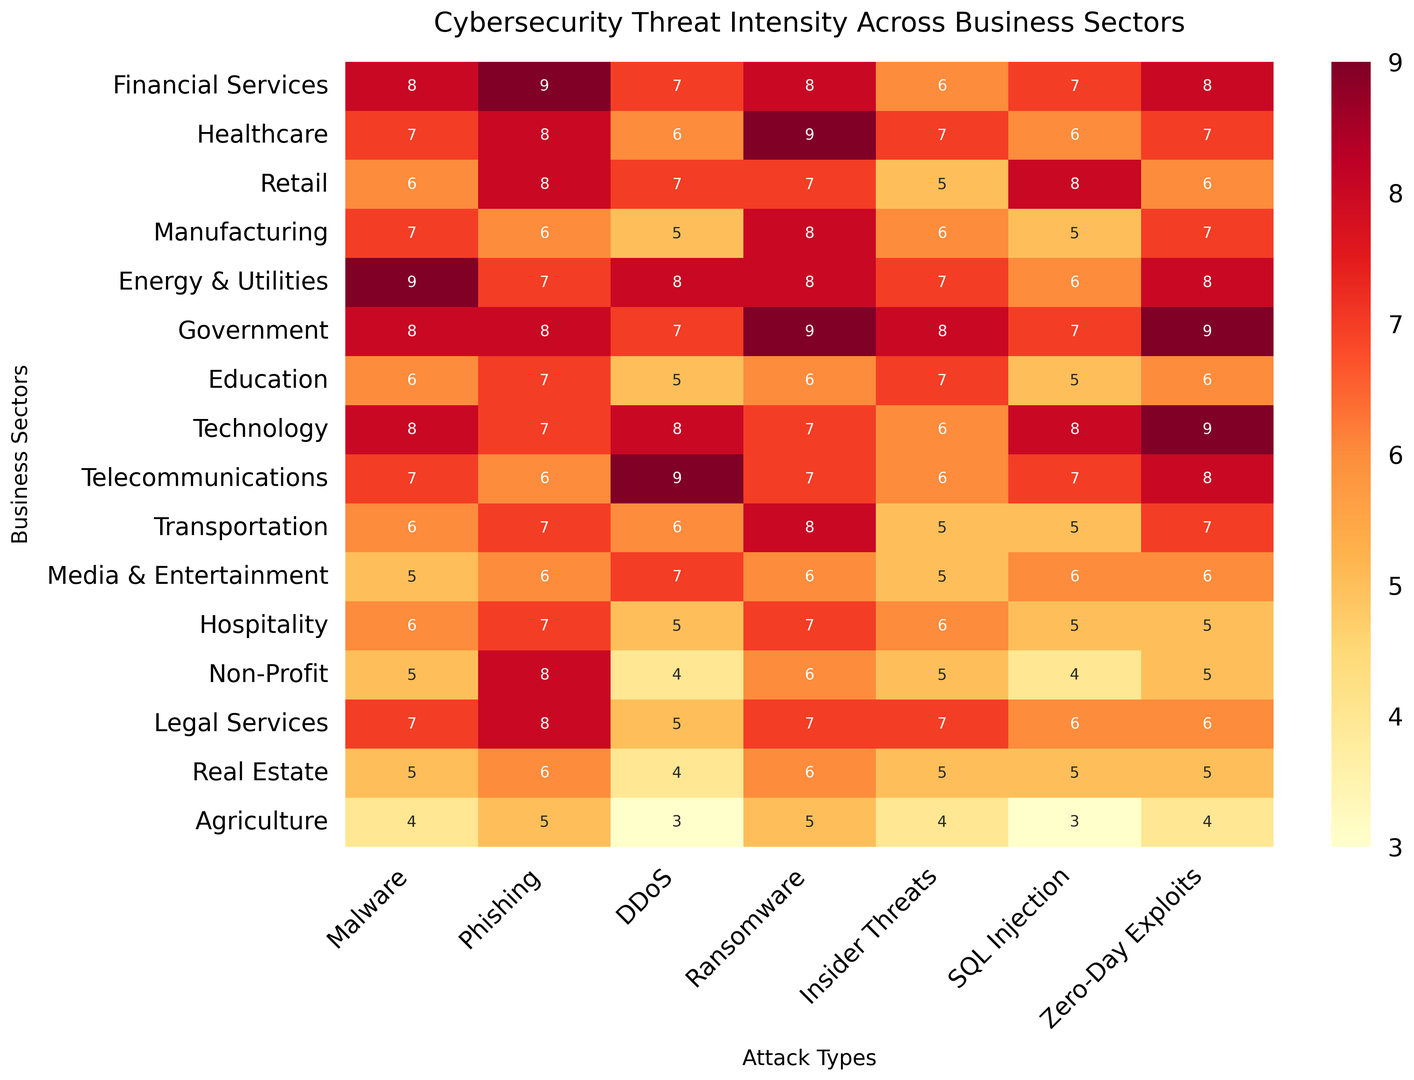Which business sector experiences the highest intensity of SQL Injection threats? The highest value for SQL Injection threats can be identified by locating the darkest cell in the SQL Injection column. The cell with '8' in the Retail row is the darkest and highest.
Answer: Retail Which attack type has the highest threat intensity across all sectors? To find the highest threat intensity across all attack types, look for the darkest cell across all columns. The maximum value is '9', which appears multiple times.
Answer: Phishing and Ransomware How does the intensity of Zero-Day Exploits in the Technology sector compare to that in the Government sector? The Technology sector has a Zero-Day Exploits value of 9, while the Government sector also has a value of 9.
Answer: They are equal Which business sector has the least intensity of DDoS attacks, and what's that value? The least intensity of DDoS attacks is found by locating the lightest cell in the DDoS column. The value '3' in the Agriculture row is the lightest.
Answer: Agriculture, 3 Compare the average threat intensity of Phishing across Education, Healthcare, and Legal Services sectors. Calculate the average by summing the Phishing values for Education (7), Healthcare (8), and Legal Services (8), then divide by 3. The sum is 7 + 8 + 8 = 23, and the average is 23/3 = 7.67.
Answer: 7.67 What is the difference in intensity of Insider Threats between Healthcare and Media & Entertainment sectors? The intensity of Insider Threats in Healthcare is 7, whereas in Media & Entertainment, it is 5. The difference is 7 - 5 = 2.
Answer: 2 In which business sector do Malware and Ransomware threats have equal intensity? Find rows where Malware and Ransomware columns have the same value. This happens in the Technology sector, with both values being 8.
Answer: Technology What is the sum of threat intensities for DDoS attacks in the Financial Services and Telecommunications sectors? Add the values for DDoS in Financial Services (7) and Telecommunications (9). The sum is 7 + 9 = 16.
Answer: 16 Which attack type shows the highest threat intensity in the Energy & Utilities sector? Look across the row for Energy & Utilities and identify the highest value. Both Malware and Ransomware have the highest values of 9.
Answer: Malware and Ransomware 